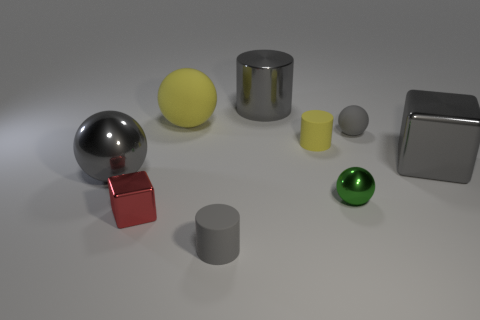Add 1 tiny matte cylinders. How many objects exist? 10 Subtract all blocks. How many objects are left? 7 Add 9 gray cubes. How many gray cubes are left? 10 Add 2 big purple cylinders. How many big purple cylinders exist? 2 Subtract 0 red balls. How many objects are left? 9 Subtract all tiny shiny cubes. Subtract all brown matte cylinders. How many objects are left? 8 